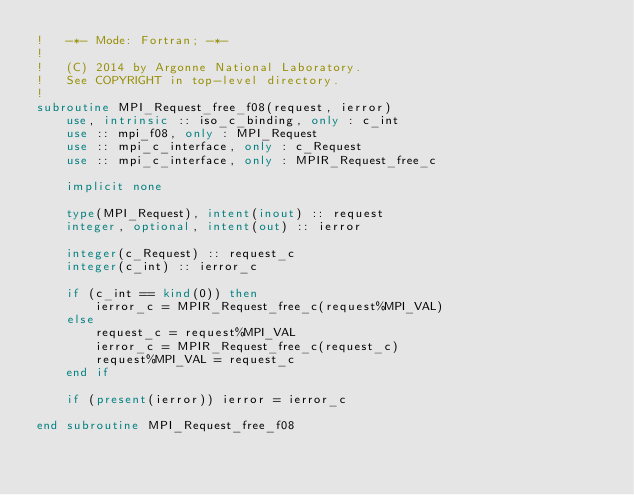Convert code to text. <code><loc_0><loc_0><loc_500><loc_500><_FORTRAN_>!   -*- Mode: Fortran; -*-
!
!   (C) 2014 by Argonne National Laboratory.
!   See COPYRIGHT in top-level directory.
!
subroutine MPI_Request_free_f08(request, ierror)
    use, intrinsic :: iso_c_binding, only : c_int
    use :: mpi_f08, only : MPI_Request
    use :: mpi_c_interface, only : c_Request
    use :: mpi_c_interface, only : MPIR_Request_free_c

    implicit none

    type(MPI_Request), intent(inout) :: request
    integer, optional, intent(out) :: ierror

    integer(c_Request) :: request_c
    integer(c_int) :: ierror_c

    if (c_int == kind(0)) then
        ierror_c = MPIR_Request_free_c(request%MPI_VAL)
    else
        request_c = request%MPI_VAL
        ierror_c = MPIR_Request_free_c(request_c)
        request%MPI_VAL = request_c
    end if

    if (present(ierror)) ierror = ierror_c

end subroutine MPI_Request_free_f08
</code> 